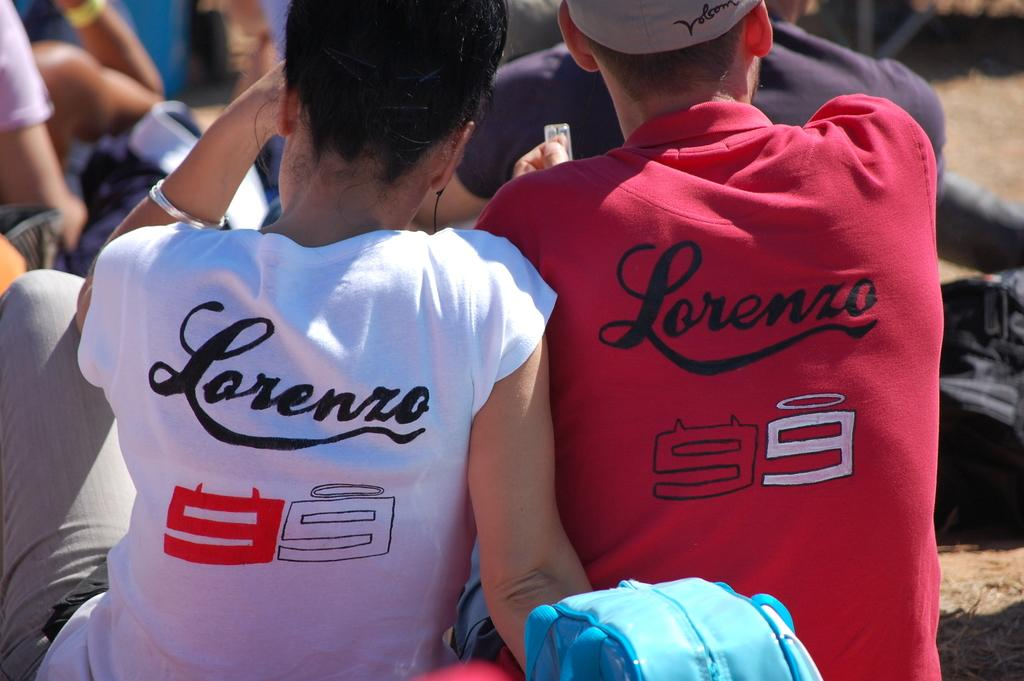<image>
Offer a succinct explanation of the picture presented. A person wearing a shirt which says Lorenzo 99. 